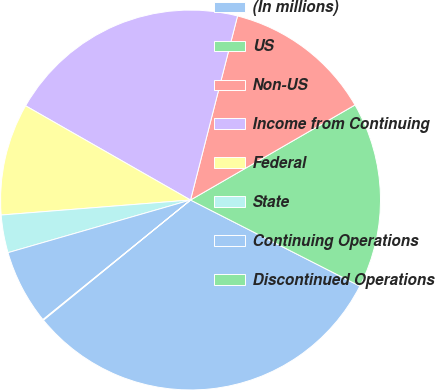Convert chart to OTSL. <chart><loc_0><loc_0><loc_500><loc_500><pie_chart><fcel>(In millions)<fcel>US<fcel>Non-US<fcel>Income from Continuing<fcel>Federal<fcel>State<fcel>Continuing Operations<fcel>Discontinued Operations<nl><fcel>31.61%<fcel>15.83%<fcel>12.68%<fcel>20.72%<fcel>9.52%<fcel>3.21%<fcel>6.37%<fcel>0.06%<nl></chart> 